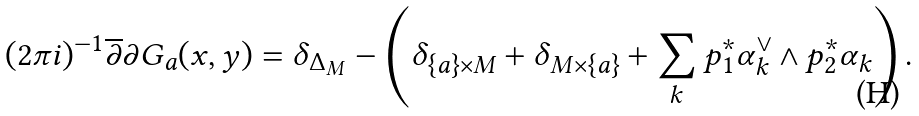<formula> <loc_0><loc_0><loc_500><loc_500>( 2 \pi i ) ^ { - 1 } \overline { \partial } \partial G _ { a } ( x , y ) = \delta _ { \Delta _ { M } } - \left ( \delta _ { \{ a \} \times M } + \delta _ { M \times \{ a \} } + \sum _ { k } p _ { 1 } ^ { * } \alpha ^ { \vee } _ { k } \wedge p _ { 2 } ^ { * } \alpha _ { k } \right ) .</formula> 